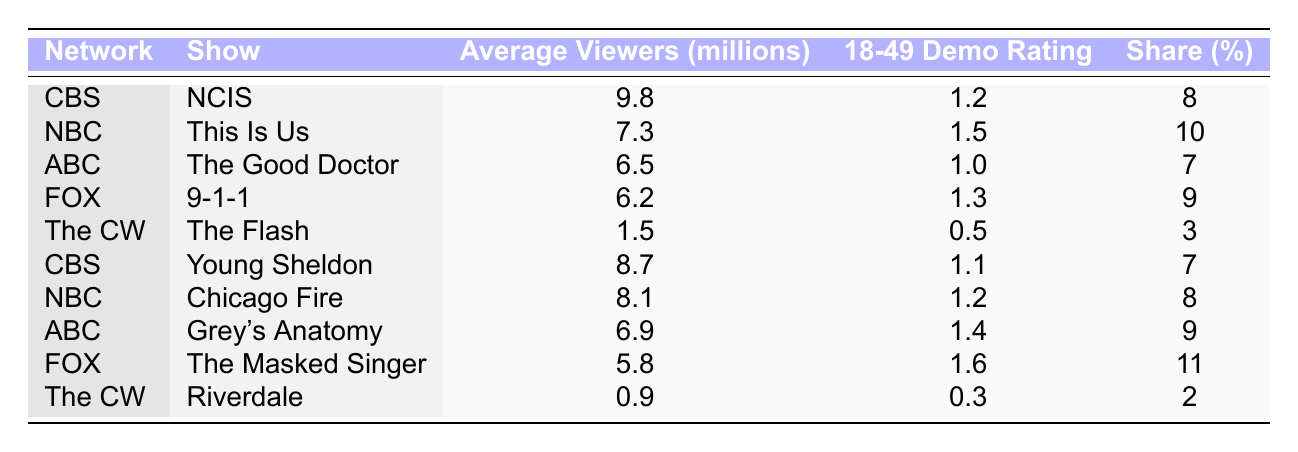What is the average number of viewers for CBS shows? The average viewers for CBS shows are NCIS (9.8 million) and Young Sheldon (8.7 million). To find the average, add them: 9.8 + 8.7 = 18.5 million, then divide by 2: 18.5 / 2 = 9.25 million.
Answer: 9.25 million Which show has the highest 18-49 demo rating? The show with the highest 18-49 demo rating is The Masked Singer with a rating of 1.6.
Answer: The Masked Singer Is the average viewership for The CW shows higher than that of FOX shows? The average viewership for The CW shows is (1.5 + 0.9) / 2 = 1.2 million, and for FOX shows is (6.2 + 5.8) / 2 = 6 million. Since 1.2 million is less than 6 million, The CW does not have higher viewership than FOX.
Answer: No What percentage of viewers watched NBC shows compared to total viewers in the table? Total average viewers from the table is 9.8 + 7.3 + 6.5 + 6.2 + 1.5 + 8.7 + 8.1 + 6.9 + 5.8 + 0.9 = 61.7 million. NBC shows are This Is Us (7.3 million) and Chicago Fire (8.1 million), totaling 15.4 million. To find the percentage: (15.4 / 61.7) * 100 = 24.97%.
Answer: 24.97% Did any show have both a lower share percentage and lower average viewership compared to other shows? Yes, Riverdale has both the lowest average viewership at 0.9 million and the lowest share at 2%. Compared to all other shows, it is lower in both metrics.
Answer: Yes What is the total share percentage of shows from ABC? The share for ABC shows The Good Doctor (7%) and Grey's Anatomy (9%) gives a total share of 7 + 9 = 16%.
Answer: 16% 